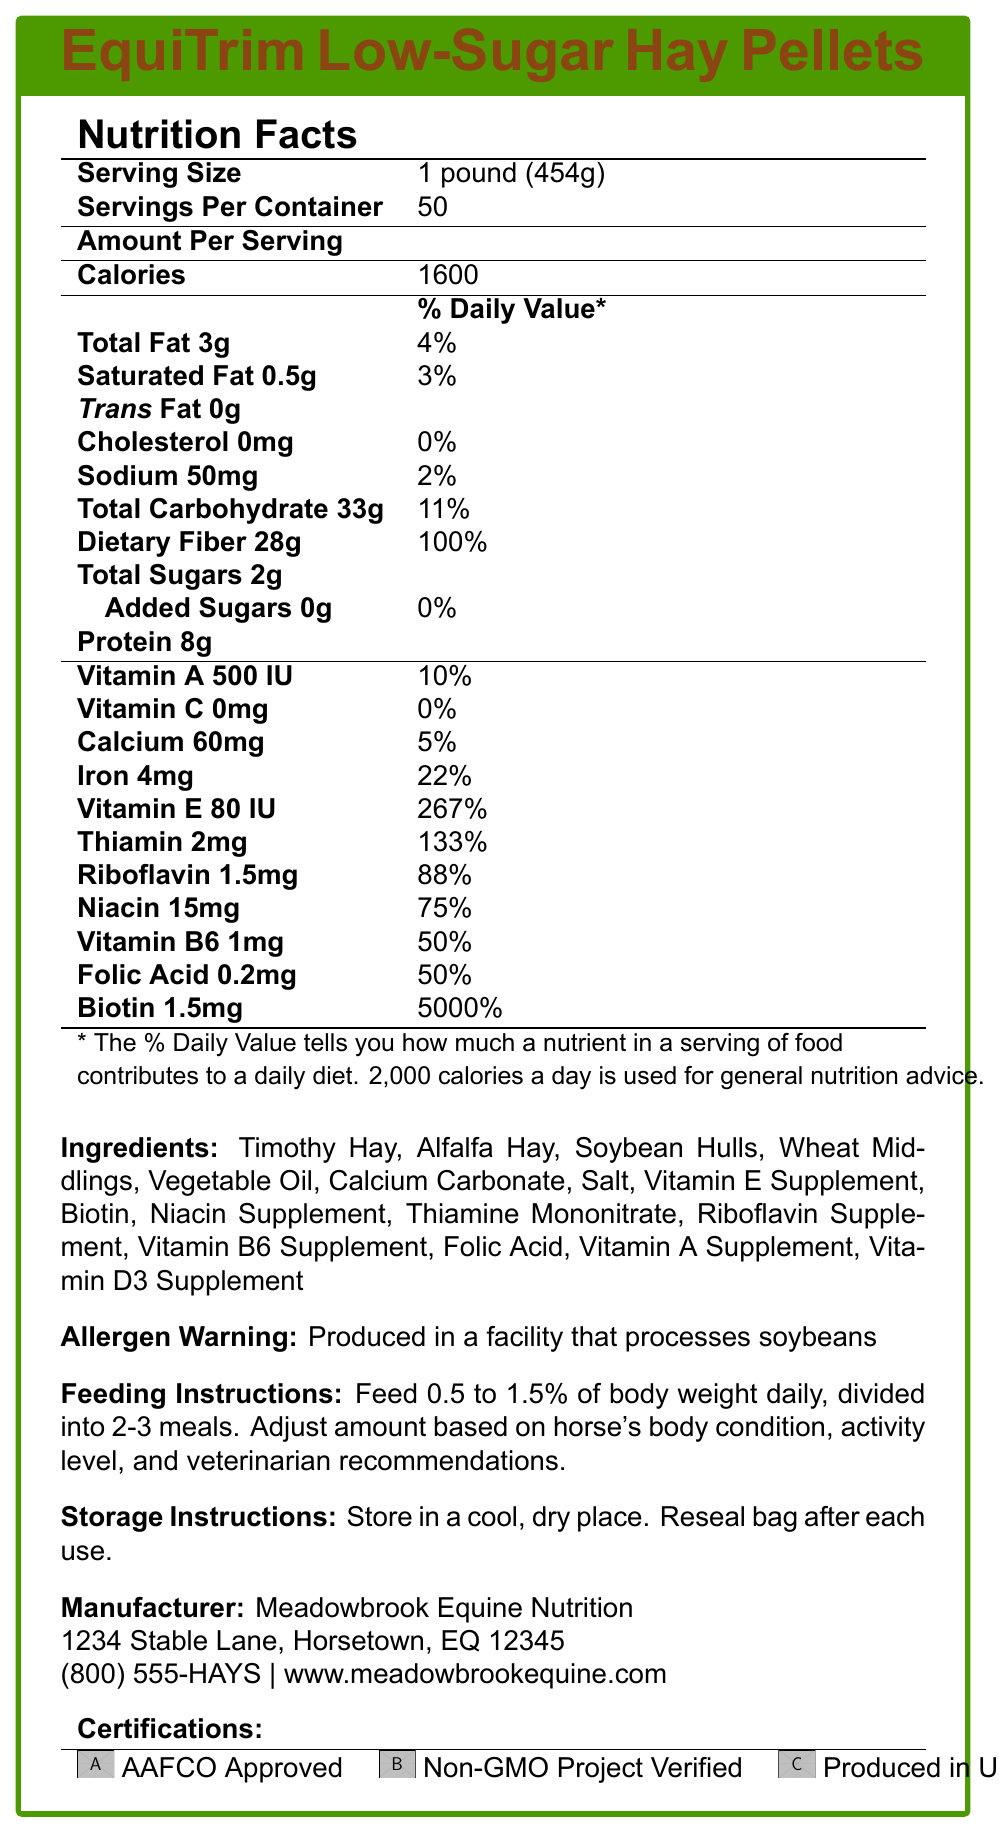What is the serving size of EquiTrim Low-Sugar Hay Pellets? The serving size is clearly stated next to "Serving Size" under the Nutrition Facts section.
Answer: 1 pound (454g) How many calories are there per serving? The number of calories per serving is listed right under the Amount Per Serving section.
Answer: 1600 How much total dietary fiber is in a serving, and what percentage of the daily value does it account for? The dietary fiber amount and its percent daily value are listed in the Total Carbohydrate section of the Nutrition Facts.
Answer: 28g, 100% What is the allergen warning for this product? The allergen warning is clearly stated in its own section under the ingredients list.
Answer: Produced in a facility that processes soybeans What are the feeding instructions for these hay pellets? The feeding instructions are explicitly mentioned under the Feeding Instructions section below the Nutrition Facts.
Answer: Feed 0.5 to 1.5% of body weight daily, divided into 2-3 meals. Adjust amount based on horse's body condition, activity level, and veterinarian recommendations. How many servings are there per container? The number of servings per container is listed under the Serving Size section.
Answer: 50 What are the main ingredients in these hay pellets? The ingredients are listed under the Ingredients section below the Nutrition Facts.
Answer: Timothy Hay, Alfalfa Hay, Soybean Hulls, Wheat Middlings, Vegetable Oil, Calcium Carbonate, Salt, Vitamin E Supplement, Biotin, Niacin Supplement, Thiamine Mononitrate, Riboflavin Supplement, Vitamin B6 Supplement, Folic Acid, Vitamin A Supplement, Vitamin D3 Supplement Which certification does this product have? A. USDA Organic B. AAFCO Approved C. Fair Trade Certified The certifications are listed under the Certifications section, and one of them is AAFCO Approved.
Answer: B What is the address of Meadowbrook Equine Nutrition? The address is provided under the Manufacturer section at the bottom of the document.
Answer: 1234 Stable Lane, Horsetown, EQ 12345 Does this product contain trans fats? The Nutrition Facts show that there are 0g of trans fats.
Answer: No Summarize the key points of this document in a few sentences. This summary captures the most critical information presented in the document including nutritional content, ingredients, feeding and storage instructions, and manufacturer details.
Answer: EquiTrim Low-Sugar Hay Pellets are designed for overweight horses, with a serving size of 1 pound (454g) and 50 servings per container. Each serving provides 1600 calories, 3g of total fat, 2g of total sugars, 28g of dietary fiber, and 8g of protein. The ingredients include Timothy Hay, Alfalfa Hay, and several vitamins and supplements. The product is produced in a facility that processes soybeans and should be stored in a cool, dry place. Feeding instructions suggest adjusting based on the horse's condition and veterinarian recommendations. The manufacturer is Meadowbrook Equine Nutrition. What is the biotin content per pound? The biotin content per pound is listed in the vitamins and minerals section of the Nutrition Facts.
Answer: 1.5mg Is the product produced in the USA? The Certifications section lists "Produced in USA" as one of the certifications.
Answer: Yes What is the vitamin C content in this product? The vitamin C content is stated as 0mg in the Nutrition Facts.
Answer: 0mg What is the phone number for contacting the manufacturer? The phone number is listed under Manufacturer Info at the bottom of the document.
Answer: (800) 555-HAYS Can the exact production method be determined from the document? While the document provides the manufacturer's address and certain certifications, it does not give explicit details about the production method used.
Answer: Not enough information 